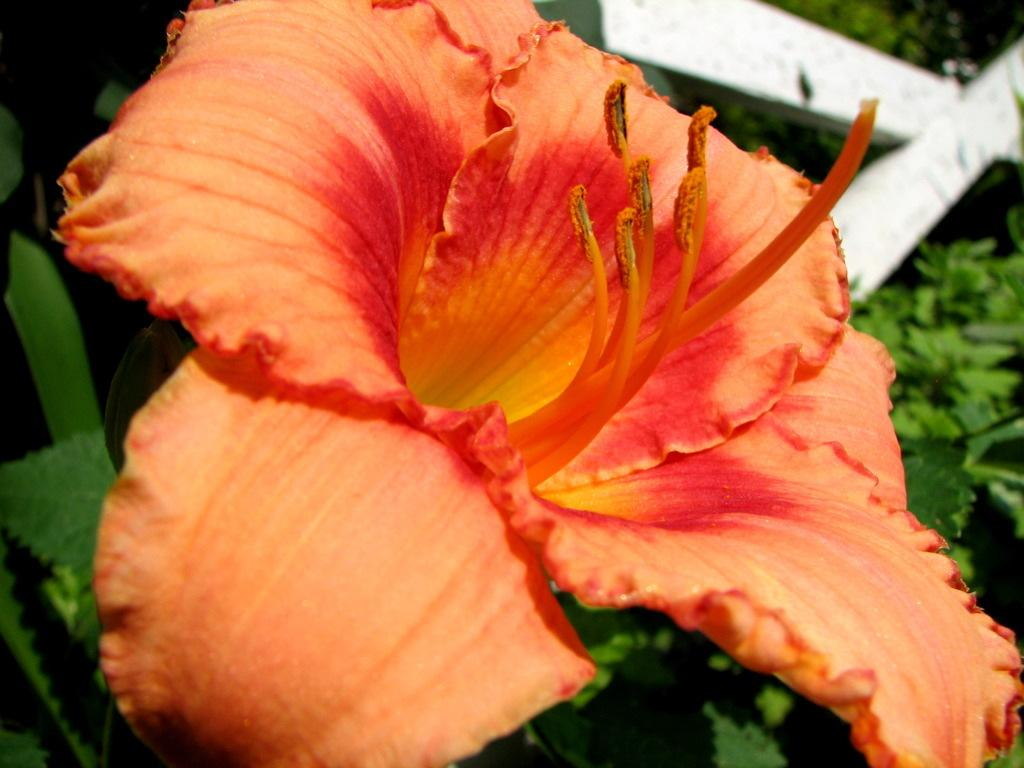What type of flower is present in the image? There is an orange color flower in the image. What is the flower a part of? The flower is part of a plant. How would you describe the background of the image? The background of the image is blurred. What else can be seen in the background besides the blurred area? There are other plants visible in the background. Can you describe any other objects in the background? There is a white color object in the background. What type of clouds can be seen in the image? There are no clouds visible in the image; the background is blurred and contains other plants and a white color object. 